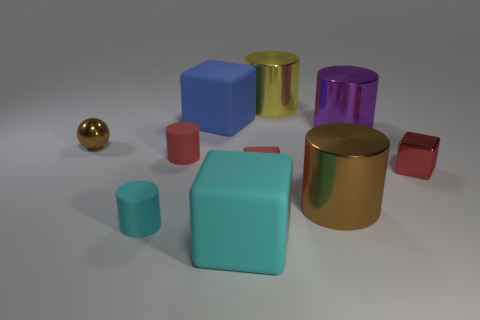Is there a small red object of the same shape as the blue thing?
Provide a short and direct response. Yes. There is a big yellow metallic thing; does it have the same shape as the matte object behind the small brown shiny sphere?
Your response must be concise. No. What number of cylinders are large yellow objects or big brown metal objects?
Your answer should be very brief. 2. There is a cyan thing that is in front of the cyan matte cylinder; what is its shape?
Keep it short and to the point. Cube. How many big blue cubes are the same material as the big brown cylinder?
Ensure brevity in your answer.  0. Is the number of small metallic cubes that are behind the purple cylinder less than the number of tiny red metallic things?
Ensure brevity in your answer.  Yes. There is a brown metallic object that is right of the brown object on the left side of the small cyan object; how big is it?
Ensure brevity in your answer.  Large. Is the color of the tiny matte block the same as the big matte thing in front of the brown metal cylinder?
Give a very brief answer. No. What is the material of the cyan object that is the same size as the blue thing?
Give a very brief answer. Rubber. Is the number of large rubber things that are in front of the tiny metallic sphere less than the number of purple things that are to the left of the tiny cyan object?
Your response must be concise. No. 